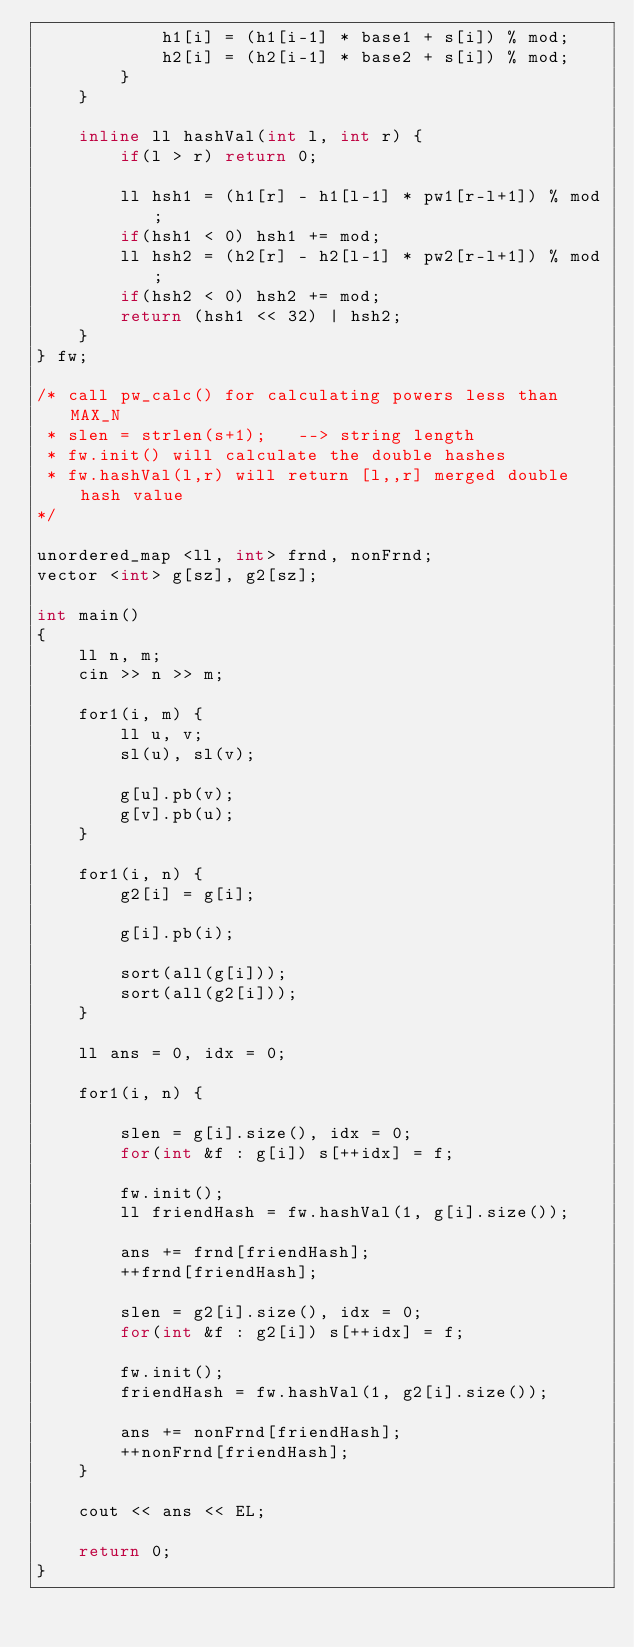Convert code to text. <code><loc_0><loc_0><loc_500><loc_500><_C++_>            h1[i] = (h1[i-1] * base1 + s[i]) % mod;
            h2[i] = (h2[i-1] * base2 + s[i]) % mod;
        }
    }

    inline ll hashVal(int l, int r) {
        if(l > r) return 0;

        ll hsh1 = (h1[r] - h1[l-1] * pw1[r-l+1]) % mod;
        if(hsh1 < 0) hsh1 += mod;
        ll hsh2 = (h2[r] - h2[l-1] * pw2[r-l+1]) % mod;
        if(hsh2 < 0) hsh2 += mod;
        return (hsh1 << 32) | hsh2;
    }
} fw;

/* call pw_calc() for calculating powers less than MAX_N
 * slen = strlen(s+1);   --> string length
 * fw.init() will calculate the double hashes
 * fw.hashVal(l,r) will return [l,,r] merged double hash value
*/

unordered_map <ll, int> frnd, nonFrnd;
vector <int> g[sz], g2[sz];

int main()
{
    ll n, m;
    cin >> n >> m;

    for1(i, m) {
        ll u, v;
        sl(u), sl(v);

        g[u].pb(v);
        g[v].pb(u);
    }

    for1(i, n) {
        g2[i] = g[i];

        g[i].pb(i);

        sort(all(g[i]));
        sort(all(g2[i]));
    }

    ll ans = 0, idx = 0;

    for1(i, n) {

        slen = g[i].size(), idx = 0;
        for(int &f : g[i]) s[++idx] = f;

        fw.init();
        ll friendHash = fw.hashVal(1, g[i].size());

        ans += frnd[friendHash];
        ++frnd[friendHash];

        slen = g2[i].size(), idx = 0;
        for(int &f : g2[i]) s[++idx] = f;

        fw.init();
        friendHash = fw.hashVal(1, g2[i].size());

        ans += nonFrnd[friendHash];
        ++nonFrnd[friendHash];
    }

    cout << ans << EL;

    return 0;
}</code> 